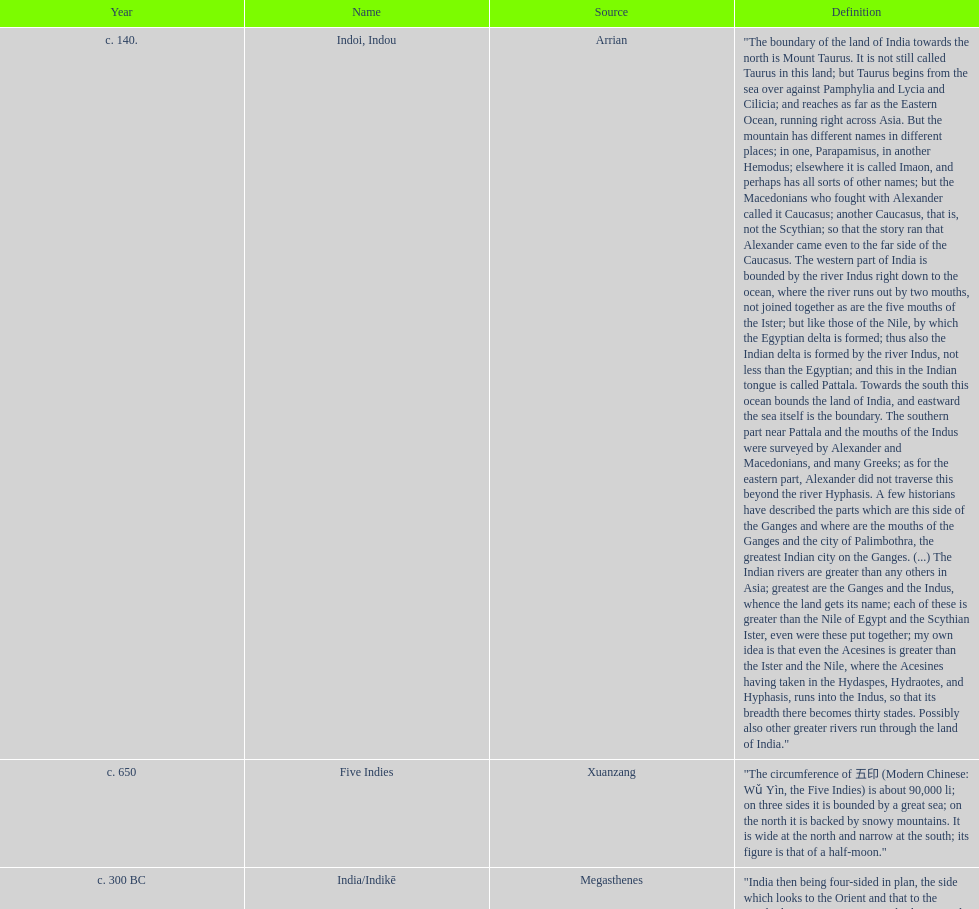What was the nation called before the book of esther called it hodu? Hidush. 